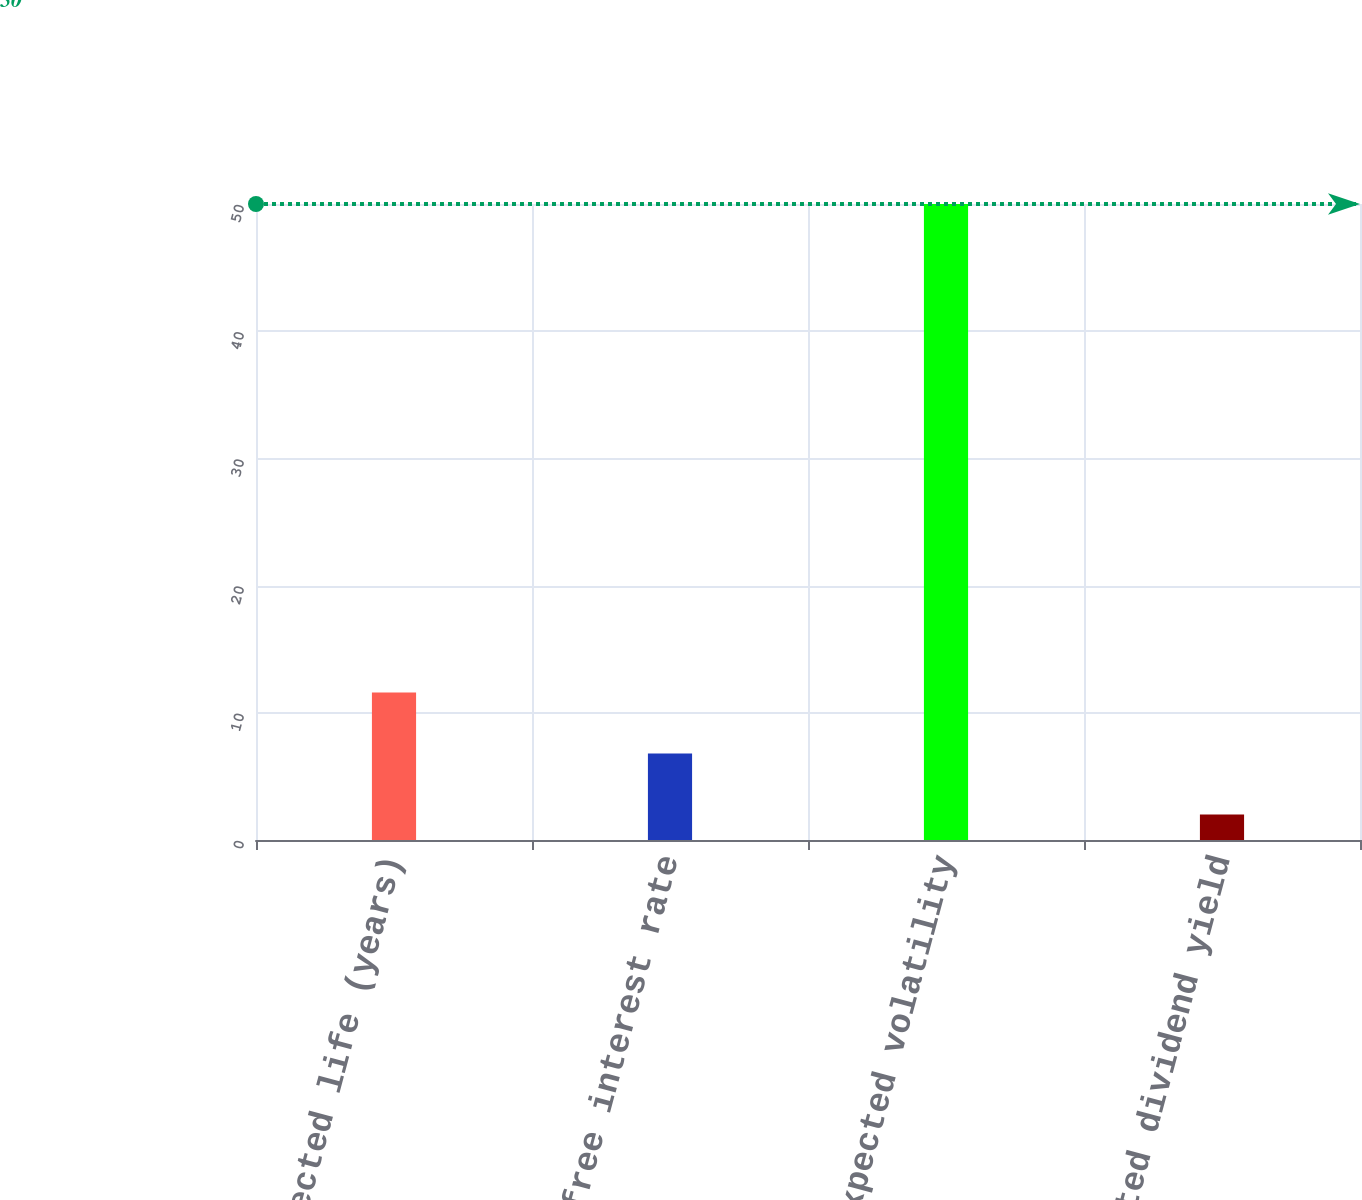Convert chart. <chart><loc_0><loc_0><loc_500><loc_500><bar_chart><fcel>Expected life (years)<fcel>Risk-free interest rate<fcel>Expected volatility<fcel>Expected dividend yield<nl><fcel>11.6<fcel>6.8<fcel>50<fcel>2<nl></chart> 